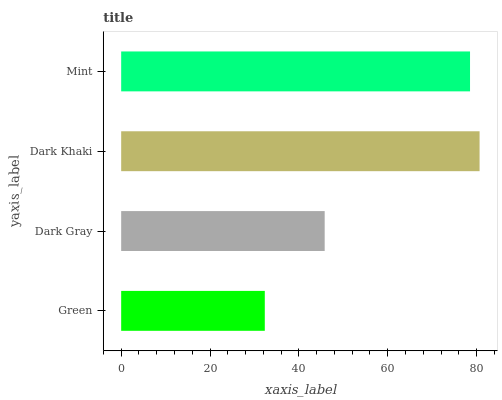Is Green the minimum?
Answer yes or no. Yes. Is Dark Khaki the maximum?
Answer yes or no. Yes. Is Dark Gray the minimum?
Answer yes or no. No. Is Dark Gray the maximum?
Answer yes or no. No. Is Dark Gray greater than Green?
Answer yes or no. Yes. Is Green less than Dark Gray?
Answer yes or no. Yes. Is Green greater than Dark Gray?
Answer yes or no. No. Is Dark Gray less than Green?
Answer yes or no. No. Is Mint the high median?
Answer yes or no. Yes. Is Dark Gray the low median?
Answer yes or no. Yes. Is Dark Gray the high median?
Answer yes or no. No. Is Mint the low median?
Answer yes or no. No. 